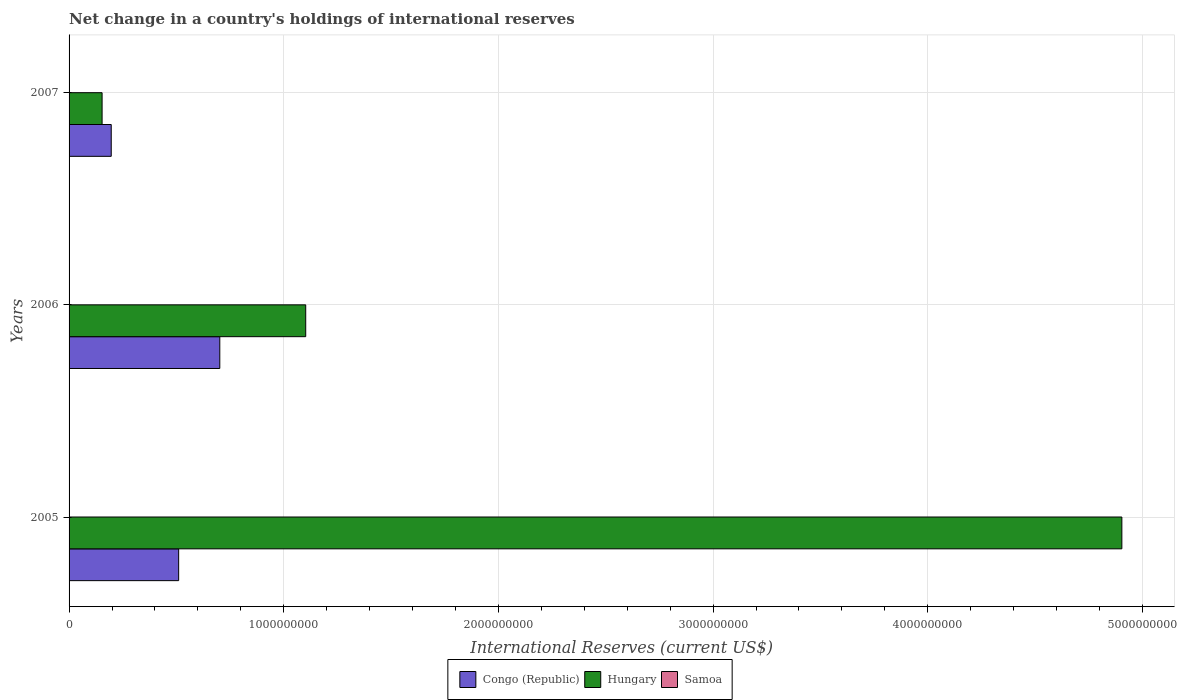Are the number of bars per tick equal to the number of legend labels?
Provide a short and direct response. No. How many bars are there on the 1st tick from the top?
Offer a terse response. 2. Across all years, what is the maximum international reserves in Hungary?
Make the answer very short. 4.90e+09. In which year was the international reserves in Congo (Republic) maximum?
Give a very brief answer. 2006. What is the total international reserves in Congo (Republic) in the graph?
Offer a terse response. 1.41e+09. What is the difference between the international reserves in Congo (Republic) in 2006 and that in 2007?
Ensure brevity in your answer.  5.06e+08. What is the difference between the international reserves in Congo (Republic) in 2006 and the international reserves in Samoa in 2007?
Keep it short and to the point. 7.02e+08. What is the average international reserves in Congo (Republic) per year?
Make the answer very short. 4.70e+08. In the year 2007, what is the difference between the international reserves in Hungary and international reserves in Congo (Republic)?
Offer a terse response. -4.26e+07. What is the ratio of the international reserves in Congo (Republic) in 2005 to that in 2006?
Your response must be concise. 0.73. Is the international reserves in Congo (Republic) in 2006 less than that in 2007?
Keep it short and to the point. No. Is the difference between the international reserves in Hungary in 2005 and 2006 greater than the difference between the international reserves in Congo (Republic) in 2005 and 2006?
Your answer should be very brief. Yes. What is the difference between the highest and the second highest international reserves in Congo (Republic)?
Offer a terse response. 1.92e+08. What is the difference between the highest and the lowest international reserves in Congo (Republic)?
Provide a short and direct response. 5.06e+08. In how many years, is the international reserves in Hungary greater than the average international reserves in Hungary taken over all years?
Keep it short and to the point. 1. How many years are there in the graph?
Make the answer very short. 3. What is the difference between two consecutive major ticks on the X-axis?
Your answer should be compact. 1.00e+09. Are the values on the major ticks of X-axis written in scientific E-notation?
Your answer should be compact. No. Does the graph contain any zero values?
Give a very brief answer. Yes. Does the graph contain grids?
Ensure brevity in your answer.  Yes. How many legend labels are there?
Keep it short and to the point. 3. What is the title of the graph?
Your response must be concise. Net change in a country's holdings of international reserves. What is the label or title of the X-axis?
Ensure brevity in your answer.  International Reserves (current US$). What is the International Reserves (current US$) in Congo (Republic) in 2005?
Your answer should be compact. 5.10e+08. What is the International Reserves (current US$) in Hungary in 2005?
Your answer should be compact. 4.90e+09. What is the International Reserves (current US$) of Samoa in 2005?
Offer a terse response. 0. What is the International Reserves (current US$) of Congo (Republic) in 2006?
Keep it short and to the point. 7.02e+08. What is the International Reserves (current US$) of Hungary in 2006?
Ensure brevity in your answer.  1.10e+09. What is the International Reserves (current US$) in Congo (Republic) in 2007?
Offer a very short reply. 1.96e+08. What is the International Reserves (current US$) in Hungary in 2007?
Offer a very short reply. 1.54e+08. Across all years, what is the maximum International Reserves (current US$) in Congo (Republic)?
Your response must be concise. 7.02e+08. Across all years, what is the maximum International Reserves (current US$) of Hungary?
Make the answer very short. 4.90e+09. Across all years, what is the minimum International Reserves (current US$) of Congo (Republic)?
Offer a terse response. 1.96e+08. Across all years, what is the minimum International Reserves (current US$) in Hungary?
Your response must be concise. 1.54e+08. What is the total International Reserves (current US$) of Congo (Republic) in the graph?
Offer a terse response. 1.41e+09. What is the total International Reserves (current US$) in Hungary in the graph?
Ensure brevity in your answer.  6.16e+09. What is the difference between the International Reserves (current US$) in Congo (Republic) in 2005 and that in 2006?
Ensure brevity in your answer.  -1.92e+08. What is the difference between the International Reserves (current US$) in Hungary in 2005 and that in 2006?
Your response must be concise. 3.80e+09. What is the difference between the International Reserves (current US$) in Congo (Republic) in 2005 and that in 2007?
Your response must be concise. 3.14e+08. What is the difference between the International Reserves (current US$) in Hungary in 2005 and that in 2007?
Offer a very short reply. 4.75e+09. What is the difference between the International Reserves (current US$) in Congo (Republic) in 2006 and that in 2007?
Give a very brief answer. 5.06e+08. What is the difference between the International Reserves (current US$) in Hungary in 2006 and that in 2007?
Keep it short and to the point. 9.49e+08. What is the difference between the International Reserves (current US$) in Congo (Republic) in 2005 and the International Reserves (current US$) in Hungary in 2006?
Your answer should be compact. -5.92e+08. What is the difference between the International Reserves (current US$) in Congo (Republic) in 2005 and the International Reserves (current US$) in Hungary in 2007?
Ensure brevity in your answer.  3.57e+08. What is the difference between the International Reserves (current US$) of Congo (Republic) in 2006 and the International Reserves (current US$) of Hungary in 2007?
Your response must be concise. 5.48e+08. What is the average International Reserves (current US$) in Congo (Republic) per year?
Your answer should be compact. 4.70e+08. What is the average International Reserves (current US$) of Hungary per year?
Your answer should be very brief. 2.05e+09. What is the average International Reserves (current US$) in Samoa per year?
Provide a succinct answer. 0. In the year 2005, what is the difference between the International Reserves (current US$) of Congo (Republic) and International Reserves (current US$) of Hungary?
Keep it short and to the point. -4.39e+09. In the year 2006, what is the difference between the International Reserves (current US$) of Congo (Republic) and International Reserves (current US$) of Hungary?
Your response must be concise. -4.00e+08. In the year 2007, what is the difference between the International Reserves (current US$) of Congo (Republic) and International Reserves (current US$) of Hungary?
Your answer should be very brief. 4.26e+07. What is the ratio of the International Reserves (current US$) in Congo (Republic) in 2005 to that in 2006?
Offer a very short reply. 0.73. What is the ratio of the International Reserves (current US$) of Hungary in 2005 to that in 2006?
Offer a terse response. 4.45. What is the ratio of the International Reserves (current US$) of Congo (Republic) in 2005 to that in 2007?
Give a very brief answer. 2.6. What is the ratio of the International Reserves (current US$) of Hungary in 2005 to that in 2007?
Provide a short and direct response. 31.88. What is the ratio of the International Reserves (current US$) of Congo (Republic) in 2006 to that in 2007?
Offer a very short reply. 3.58. What is the ratio of the International Reserves (current US$) in Hungary in 2006 to that in 2007?
Make the answer very short. 7.17. What is the difference between the highest and the second highest International Reserves (current US$) in Congo (Republic)?
Your answer should be compact. 1.92e+08. What is the difference between the highest and the second highest International Reserves (current US$) in Hungary?
Provide a short and direct response. 3.80e+09. What is the difference between the highest and the lowest International Reserves (current US$) in Congo (Republic)?
Give a very brief answer. 5.06e+08. What is the difference between the highest and the lowest International Reserves (current US$) of Hungary?
Offer a terse response. 4.75e+09. 